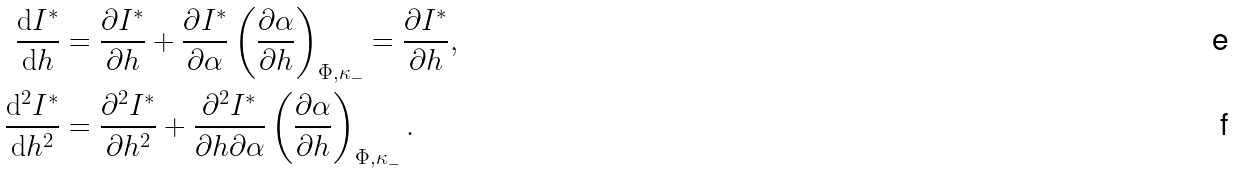<formula> <loc_0><loc_0><loc_500><loc_500>\frac { \mathrm d I ^ { * } } { \mathrm d h } & = \frac { \partial I ^ { * } } { \partial h } + \frac { \partial I ^ { * } } { \partial \alpha } \left ( \frac { \partial \alpha } { \partial h } \right ) _ { \Phi , \kappa _ { - } } = \frac { \partial I ^ { * } } { \partial h } , \\ \frac { \mathrm d ^ { 2 } I ^ { * } } { \mathrm d h ^ { 2 } } & = \frac { \partial ^ { 2 } I ^ { * } } { \partial h ^ { 2 } } + \frac { \partial ^ { 2 } I ^ { * } } { \partial h \partial \alpha } \left ( \frac { \partial \alpha } { \partial h } \right ) _ { \Phi , \kappa _ { - } } .</formula> 